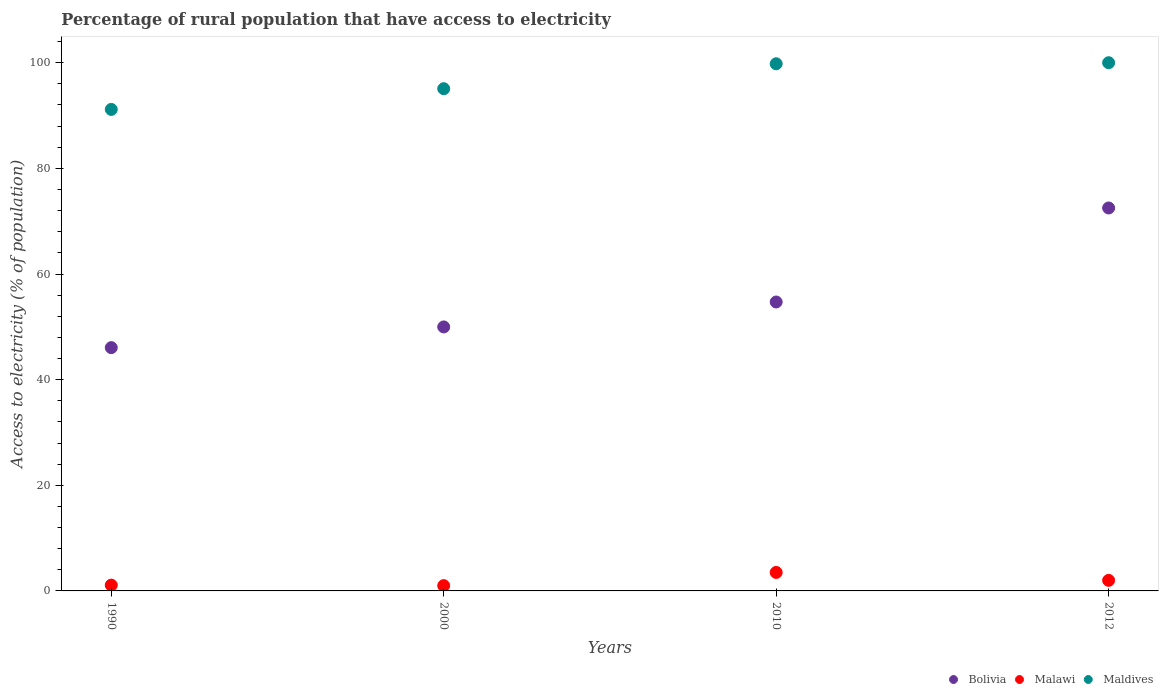Is the number of dotlines equal to the number of legend labels?
Your answer should be very brief. Yes. What is the percentage of rural population that have access to electricity in Maldives in 2000?
Ensure brevity in your answer.  95.08. Across all years, what is the maximum percentage of rural population that have access to electricity in Maldives?
Make the answer very short. 100. Across all years, what is the minimum percentage of rural population that have access to electricity in Malawi?
Provide a short and direct response. 1. What is the total percentage of rural population that have access to electricity in Maldives in the graph?
Your answer should be very brief. 386.04. What is the difference between the percentage of rural population that have access to electricity in Bolivia in 1990 and that in 2012?
Provide a succinct answer. -26.44. What is the difference between the percentage of rural population that have access to electricity in Malawi in 1990 and the percentage of rural population that have access to electricity in Maldives in 2012?
Keep it short and to the point. -98.9. What is the average percentage of rural population that have access to electricity in Malawi per year?
Offer a very short reply. 1.9. In the year 2010, what is the difference between the percentage of rural population that have access to electricity in Malawi and percentage of rural population that have access to electricity in Bolivia?
Make the answer very short. -51.2. What is the ratio of the percentage of rural population that have access to electricity in Bolivia in 2000 to that in 2010?
Provide a succinct answer. 0.91. Is the percentage of rural population that have access to electricity in Malawi in 2000 less than that in 2010?
Provide a succinct answer. Yes. What is the difference between the highest and the second highest percentage of rural population that have access to electricity in Malawi?
Keep it short and to the point. 1.5. Is the sum of the percentage of rural population that have access to electricity in Malawi in 1990 and 2010 greater than the maximum percentage of rural population that have access to electricity in Maldives across all years?
Offer a terse response. No. How many dotlines are there?
Make the answer very short. 3. How many years are there in the graph?
Provide a short and direct response. 4. What is the difference between two consecutive major ticks on the Y-axis?
Ensure brevity in your answer.  20. Are the values on the major ticks of Y-axis written in scientific E-notation?
Make the answer very short. No. Where does the legend appear in the graph?
Your response must be concise. Bottom right. How many legend labels are there?
Keep it short and to the point. 3. How are the legend labels stacked?
Make the answer very short. Horizontal. What is the title of the graph?
Your answer should be compact. Percentage of rural population that have access to electricity. What is the label or title of the Y-axis?
Your response must be concise. Access to electricity (% of population). What is the Access to electricity (% of population) in Bolivia in 1990?
Keep it short and to the point. 46.06. What is the Access to electricity (% of population) of Malawi in 1990?
Provide a short and direct response. 1.1. What is the Access to electricity (% of population) of Maldives in 1990?
Your response must be concise. 91.16. What is the Access to electricity (% of population) of Bolivia in 2000?
Provide a succinct answer. 49.98. What is the Access to electricity (% of population) of Malawi in 2000?
Your response must be concise. 1. What is the Access to electricity (% of population) of Maldives in 2000?
Provide a succinct answer. 95.08. What is the Access to electricity (% of population) of Bolivia in 2010?
Keep it short and to the point. 54.7. What is the Access to electricity (% of population) in Maldives in 2010?
Keep it short and to the point. 99.8. What is the Access to electricity (% of population) of Bolivia in 2012?
Make the answer very short. 72.5. What is the Access to electricity (% of population) in Maldives in 2012?
Give a very brief answer. 100. Across all years, what is the maximum Access to electricity (% of population) in Bolivia?
Your response must be concise. 72.5. Across all years, what is the maximum Access to electricity (% of population) in Malawi?
Provide a succinct answer. 3.5. Across all years, what is the minimum Access to electricity (% of population) of Bolivia?
Ensure brevity in your answer.  46.06. Across all years, what is the minimum Access to electricity (% of population) in Malawi?
Give a very brief answer. 1. Across all years, what is the minimum Access to electricity (% of population) of Maldives?
Your answer should be compact. 91.16. What is the total Access to electricity (% of population) of Bolivia in the graph?
Your answer should be very brief. 223.24. What is the total Access to electricity (% of population) in Maldives in the graph?
Provide a short and direct response. 386.04. What is the difference between the Access to electricity (% of population) of Bolivia in 1990 and that in 2000?
Your answer should be compact. -3.92. What is the difference between the Access to electricity (% of population) in Malawi in 1990 and that in 2000?
Make the answer very short. 0.1. What is the difference between the Access to electricity (% of population) of Maldives in 1990 and that in 2000?
Provide a short and direct response. -3.92. What is the difference between the Access to electricity (% of population) of Bolivia in 1990 and that in 2010?
Offer a terse response. -8.64. What is the difference between the Access to electricity (% of population) in Malawi in 1990 and that in 2010?
Offer a very short reply. -2.4. What is the difference between the Access to electricity (% of population) of Maldives in 1990 and that in 2010?
Offer a very short reply. -8.64. What is the difference between the Access to electricity (% of population) in Bolivia in 1990 and that in 2012?
Provide a short and direct response. -26.44. What is the difference between the Access to electricity (% of population) of Maldives in 1990 and that in 2012?
Give a very brief answer. -8.84. What is the difference between the Access to electricity (% of population) of Bolivia in 2000 and that in 2010?
Offer a very short reply. -4.72. What is the difference between the Access to electricity (% of population) in Malawi in 2000 and that in 2010?
Make the answer very short. -2.5. What is the difference between the Access to electricity (% of population) in Maldives in 2000 and that in 2010?
Give a very brief answer. -4.72. What is the difference between the Access to electricity (% of population) of Bolivia in 2000 and that in 2012?
Keep it short and to the point. -22.52. What is the difference between the Access to electricity (% of population) of Malawi in 2000 and that in 2012?
Offer a terse response. -1. What is the difference between the Access to electricity (% of population) in Maldives in 2000 and that in 2012?
Offer a very short reply. -4.92. What is the difference between the Access to electricity (% of population) of Bolivia in 2010 and that in 2012?
Provide a succinct answer. -17.8. What is the difference between the Access to electricity (% of population) in Malawi in 2010 and that in 2012?
Your answer should be very brief. 1.5. What is the difference between the Access to electricity (% of population) in Bolivia in 1990 and the Access to electricity (% of population) in Malawi in 2000?
Provide a succinct answer. 45.06. What is the difference between the Access to electricity (% of population) of Bolivia in 1990 and the Access to electricity (% of population) of Maldives in 2000?
Keep it short and to the point. -49.02. What is the difference between the Access to electricity (% of population) in Malawi in 1990 and the Access to electricity (% of population) in Maldives in 2000?
Provide a short and direct response. -93.98. What is the difference between the Access to electricity (% of population) in Bolivia in 1990 and the Access to electricity (% of population) in Malawi in 2010?
Make the answer very short. 42.56. What is the difference between the Access to electricity (% of population) in Bolivia in 1990 and the Access to electricity (% of population) in Maldives in 2010?
Your answer should be compact. -53.74. What is the difference between the Access to electricity (% of population) of Malawi in 1990 and the Access to electricity (% of population) of Maldives in 2010?
Your answer should be compact. -98.7. What is the difference between the Access to electricity (% of population) in Bolivia in 1990 and the Access to electricity (% of population) in Malawi in 2012?
Keep it short and to the point. 44.06. What is the difference between the Access to electricity (% of population) in Bolivia in 1990 and the Access to electricity (% of population) in Maldives in 2012?
Ensure brevity in your answer.  -53.94. What is the difference between the Access to electricity (% of population) of Malawi in 1990 and the Access to electricity (% of population) of Maldives in 2012?
Keep it short and to the point. -98.9. What is the difference between the Access to electricity (% of population) in Bolivia in 2000 and the Access to electricity (% of population) in Malawi in 2010?
Provide a short and direct response. 46.48. What is the difference between the Access to electricity (% of population) of Bolivia in 2000 and the Access to electricity (% of population) of Maldives in 2010?
Ensure brevity in your answer.  -49.82. What is the difference between the Access to electricity (% of population) of Malawi in 2000 and the Access to electricity (% of population) of Maldives in 2010?
Provide a succinct answer. -98.8. What is the difference between the Access to electricity (% of population) in Bolivia in 2000 and the Access to electricity (% of population) in Malawi in 2012?
Give a very brief answer. 47.98. What is the difference between the Access to electricity (% of population) of Bolivia in 2000 and the Access to electricity (% of population) of Maldives in 2012?
Make the answer very short. -50.02. What is the difference between the Access to electricity (% of population) in Malawi in 2000 and the Access to electricity (% of population) in Maldives in 2012?
Offer a very short reply. -99. What is the difference between the Access to electricity (% of population) of Bolivia in 2010 and the Access to electricity (% of population) of Malawi in 2012?
Provide a succinct answer. 52.7. What is the difference between the Access to electricity (% of population) of Bolivia in 2010 and the Access to electricity (% of population) of Maldives in 2012?
Keep it short and to the point. -45.3. What is the difference between the Access to electricity (% of population) of Malawi in 2010 and the Access to electricity (% of population) of Maldives in 2012?
Your answer should be very brief. -96.5. What is the average Access to electricity (% of population) in Bolivia per year?
Your answer should be very brief. 55.81. What is the average Access to electricity (% of population) of Malawi per year?
Your answer should be compact. 1.9. What is the average Access to electricity (% of population) of Maldives per year?
Keep it short and to the point. 96.51. In the year 1990, what is the difference between the Access to electricity (% of population) of Bolivia and Access to electricity (% of population) of Malawi?
Offer a very short reply. 44.96. In the year 1990, what is the difference between the Access to electricity (% of population) in Bolivia and Access to electricity (% of population) in Maldives?
Your response must be concise. -45.1. In the year 1990, what is the difference between the Access to electricity (% of population) in Malawi and Access to electricity (% of population) in Maldives?
Your answer should be very brief. -90.06. In the year 2000, what is the difference between the Access to electricity (% of population) of Bolivia and Access to electricity (% of population) of Malawi?
Ensure brevity in your answer.  48.98. In the year 2000, what is the difference between the Access to electricity (% of population) in Bolivia and Access to electricity (% of population) in Maldives?
Your answer should be compact. -45.1. In the year 2000, what is the difference between the Access to electricity (% of population) in Malawi and Access to electricity (% of population) in Maldives?
Your answer should be compact. -94.08. In the year 2010, what is the difference between the Access to electricity (% of population) of Bolivia and Access to electricity (% of population) of Malawi?
Give a very brief answer. 51.2. In the year 2010, what is the difference between the Access to electricity (% of population) of Bolivia and Access to electricity (% of population) of Maldives?
Offer a very short reply. -45.1. In the year 2010, what is the difference between the Access to electricity (% of population) of Malawi and Access to electricity (% of population) of Maldives?
Offer a terse response. -96.3. In the year 2012, what is the difference between the Access to electricity (% of population) of Bolivia and Access to electricity (% of population) of Malawi?
Keep it short and to the point. 70.5. In the year 2012, what is the difference between the Access to electricity (% of population) in Bolivia and Access to electricity (% of population) in Maldives?
Offer a very short reply. -27.5. In the year 2012, what is the difference between the Access to electricity (% of population) in Malawi and Access to electricity (% of population) in Maldives?
Ensure brevity in your answer.  -98. What is the ratio of the Access to electricity (% of population) of Bolivia in 1990 to that in 2000?
Provide a succinct answer. 0.92. What is the ratio of the Access to electricity (% of population) of Malawi in 1990 to that in 2000?
Offer a very short reply. 1.1. What is the ratio of the Access to electricity (% of population) in Maldives in 1990 to that in 2000?
Your answer should be very brief. 0.96. What is the ratio of the Access to electricity (% of population) in Bolivia in 1990 to that in 2010?
Your response must be concise. 0.84. What is the ratio of the Access to electricity (% of population) of Malawi in 1990 to that in 2010?
Give a very brief answer. 0.31. What is the ratio of the Access to electricity (% of population) in Maldives in 1990 to that in 2010?
Ensure brevity in your answer.  0.91. What is the ratio of the Access to electricity (% of population) of Bolivia in 1990 to that in 2012?
Your response must be concise. 0.64. What is the ratio of the Access to electricity (% of population) in Malawi in 1990 to that in 2012?
Offer a very short reply. 0.55. What is the ratio of the Access to electricity (% of population) of Maldives in 1990 to that in 2012?
Provide a short and direct response. 0.91. What is the ratio of the Access to electricity (% of population) in Bolivia in 2000 to that in 2010?
Offer a very short reply. 0.91. What is the ratio of the Access to electricity (% of population) in Malawi in 2000 to that in 2010?
Keep it short and to the point. 0.29. What is the ratio of the Access to electricity (% of population) of Maldives in 2000 to that in 2010?
Offer a very short reply. 0.95. What is the ratio of the Access to electricity (% of population) of Bolivia in 2000 to that in 2012?
Keep it short and to the point. 0.69. What is the ratio of the Access to electricity (% of population) in Malawi in 2000 to that in 2012?
Offer a very short reply. 0.5. What is the ratio of the Access to electricity (% of population) in Maldives in 2000 to that in 2012?
Provide a short and direct response. 0.95. What is the ratio of the Access to electricity (% of population) of Bolivia in 2010 to that in 2012?
Provide a succinct answer. 0.75. What is the difference between the highest and the second highest Access to electricity (% of population) in Bolivia?
Offer a very short reply. 17.8. What is the difference between the highest and the lowest Access to electricity (% of population) in Bolivia?
Provide a succinct answer. 26.44. What is the difference between the highest and the lowest Access to electricity (% of population) of Maldives?
Make the answer very short. 8.84. 